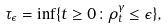Convert formula to latex. <formula><loc_0><loc_0><loc_500><loc_500>\tau _ { \epsilon } = \inf \{ t \geq 0 \colon \rho ^ { \gamma } _ { t } \leq \epsilon \} ,</formula> 